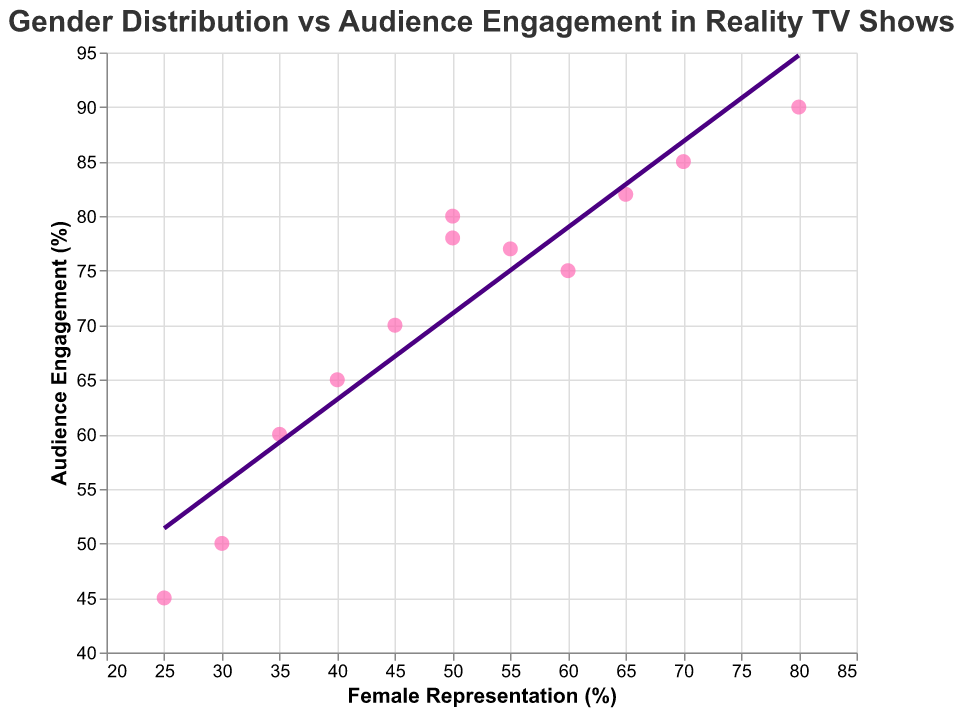What is the title of the figure? The title of the figure is located at the top of the chart, summarizing what the plot is about.
Answer: Gender Distribution vs Audience Engagement in Reality TV Shows What is the percentage of female representation in Reality Show K? Locate the point that represents Reality Show K on the scatter plot, then check its x-axis value for the female representation percentage.
Answer: 80% Which show has the lowest audience engagement level? To find the show with the lowest engagement, look for the data point with the smallest y-axis value and check its tooltip for the show name.
Answer: Reality Show L How many shows have a female representation of 50%? Identify the points where the x-axis value is 50% and count the total.
Answer: 2 Which show has the highest audience engagement level? Look for the data point with the largest y-axis value and check its tooltip for the show name.
Answer: Reality Show K What is the average audience engagement level of shows with more than 60% female representation? Identify the shows with female representation greater than 60% by checking the x-axis value, then sum their y-axis (engagement levels) and divide by the number of such shows. Shows to consider: Reality Show D, Reality Show H, Reality Show K. Their engagement levels are 85, 82, and 90. The total is 85 + 82 + 90 = 257. There are 3 shows so the average is 257/3 = 85.67
Answer: 85.67% Is there a positive correlation between female representation and audience engagement? Observe the direction of the trend line: if it slopes upwards, there's a positive correlation.
Answer: Yes Which reality show has nearly equal female representation and audience engagement levels? Compare the x-axis and y-axis values for equality or close similarity, check their tooltips. Reality Show J has 50% female representation and 78% engagement which are roughly close compared to others.
Answer: Reality Show J What is the trend line used for in this plot? The trend line shows the general trend or correlation between female representation and audience engagement. It helps identify whether higher female representation tends to associate with higher or lower audience engagement.
Answer: To show the correlation What is the range of female representation percentage in these reality shows? Observe the x-axis values from the minimum to maximum to find the range.
Answer: 25% to 80% 